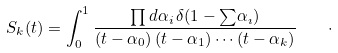<formula> <loc_0><loc_0><loc_500><loc_500>S _ { k } ( t ) = \int _ { 0 } ^ { 1 } \frac { \prod d \alpha _ { i } \, \delta ( 1 - { \sum } \alpha _ { \imath } ) } { ( t - \alpha _ { 0 } ) \, ( t - \alpha _ { 1 } ) \cdots ( t - \alpha _ { k } ) } \quad \cdot</formula> 